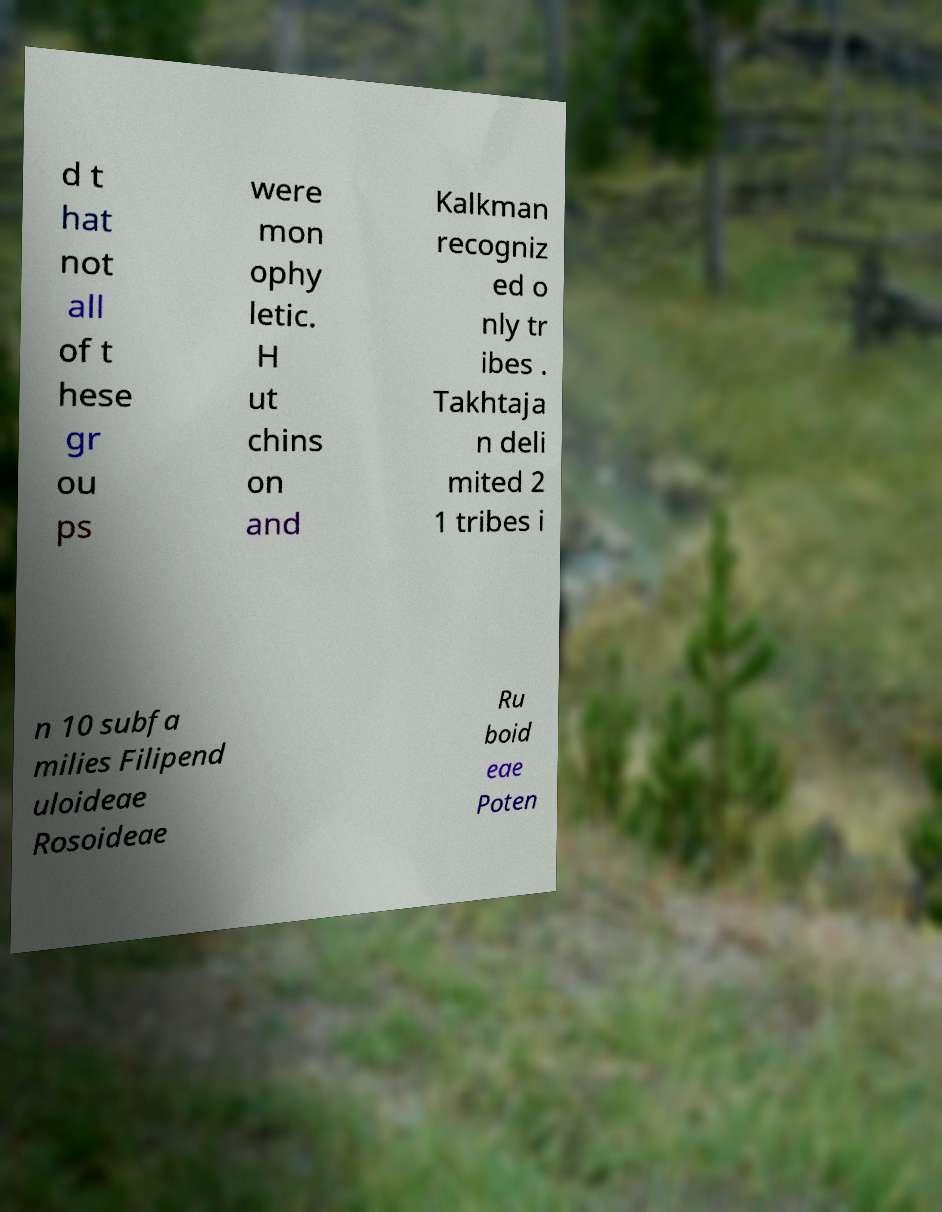What messages or text are displayed in this image? I need them in a readable, typed format. d t hat not all of t hese gr ou ps were mon ophy letic. H ut chins on and Kalkman recogniz ed o nly tr ibes . Takhtaja n deli mited 2 1 tribes i n 10 subfa milies Filipend uloideae Rosoideae Ru boid eae Poten 